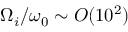Convert formula to latex. <formula><loc_0><loc_0><loc_500><loc_500>\Omega _ { i } / \omega _ { 0 } \sim O ( 1 0 ^ { 2 } )</formula> 